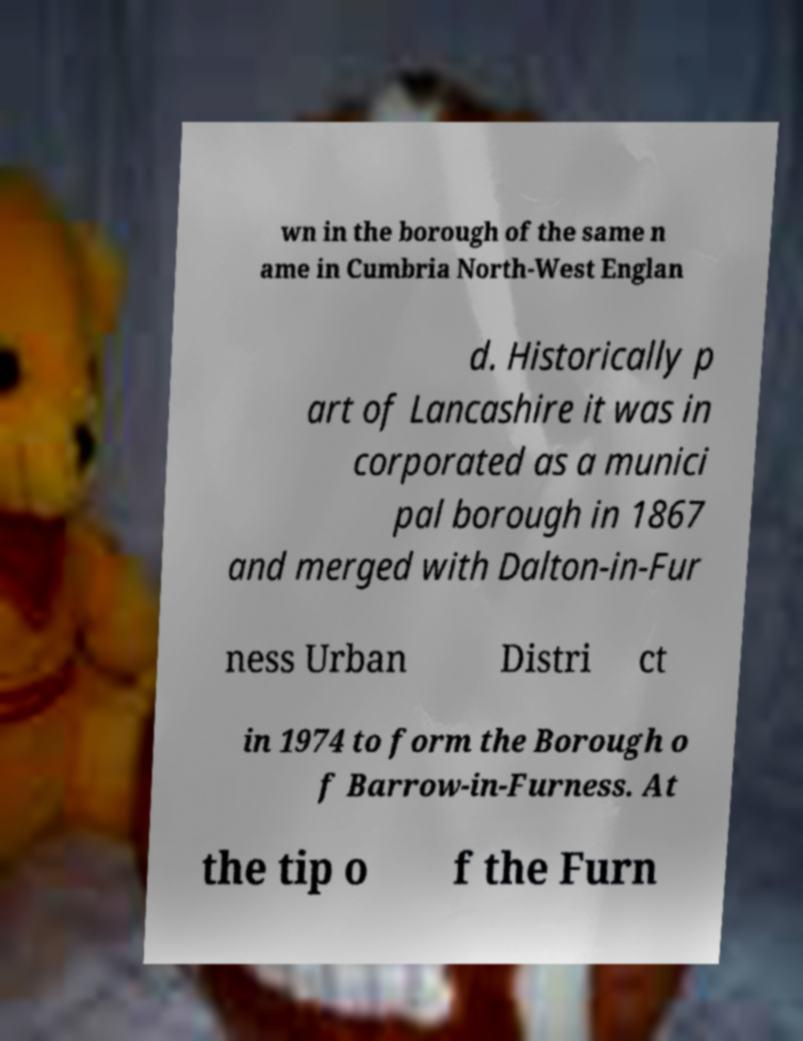Could you extract and type out the text from this image? wn in the borough of the same n ame in Cumbria North-West Englan d. Historically p art of Lancashire it was in corporated as a munici pal borough in 1867 and merged with Dalton-in-Fur ness Urban Distri ct in 1974 to form the Borough o f Barrow-in-Furness. At the tip o f the Furn 